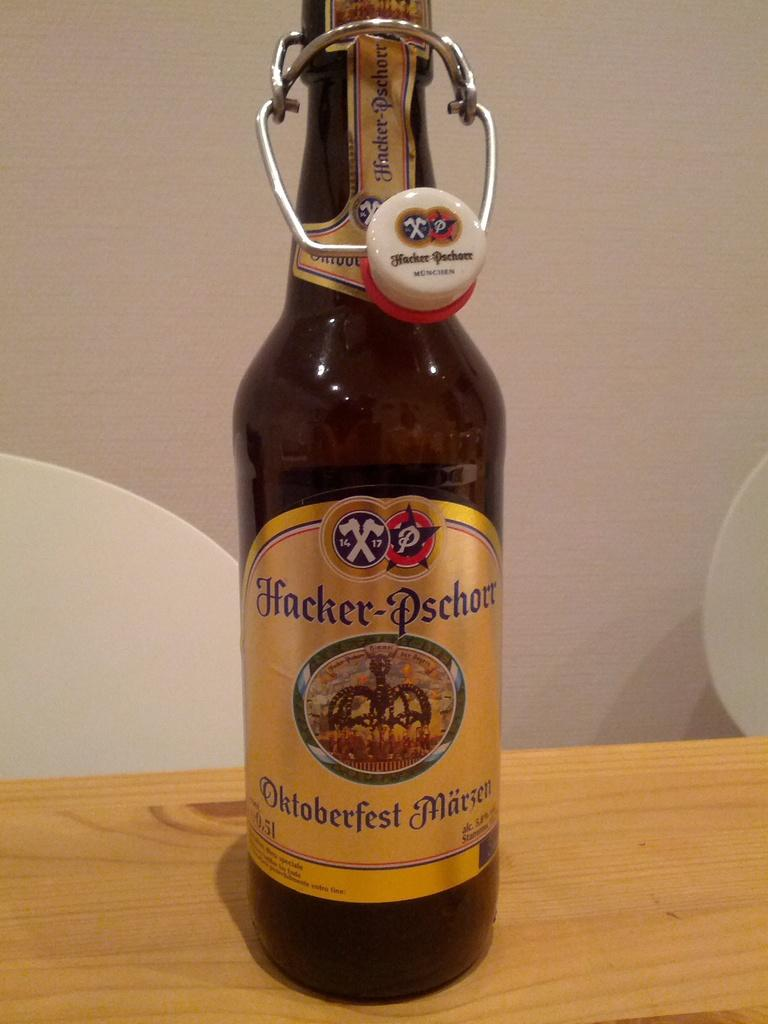<image>
Summarize the visual content of the image. a bottle of hacker-pschorr oktoberfest marzen with a gold label 